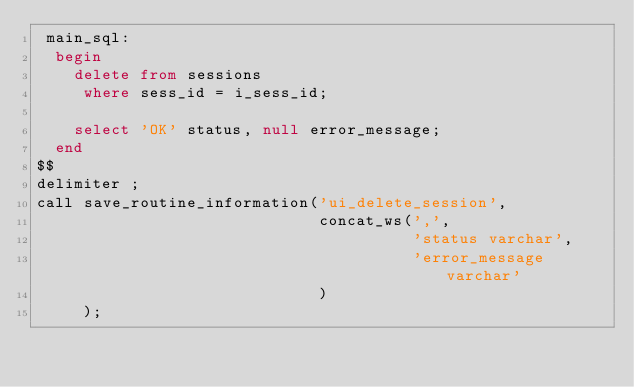<code> <loc_0><loc_0><loc_500><loc_500><_SQL_> main_sql:
  begin
    delete from sessions
     where sess_id = i_sess_id;

    select 'OK' status, null error_message;
  end
$$
delimiter ;
call save_routine_information('ui_delete_session',
                              concat_ws(',',
                                        'status varchar',
                                        'error_message varchar'
                              )
     );</code> 